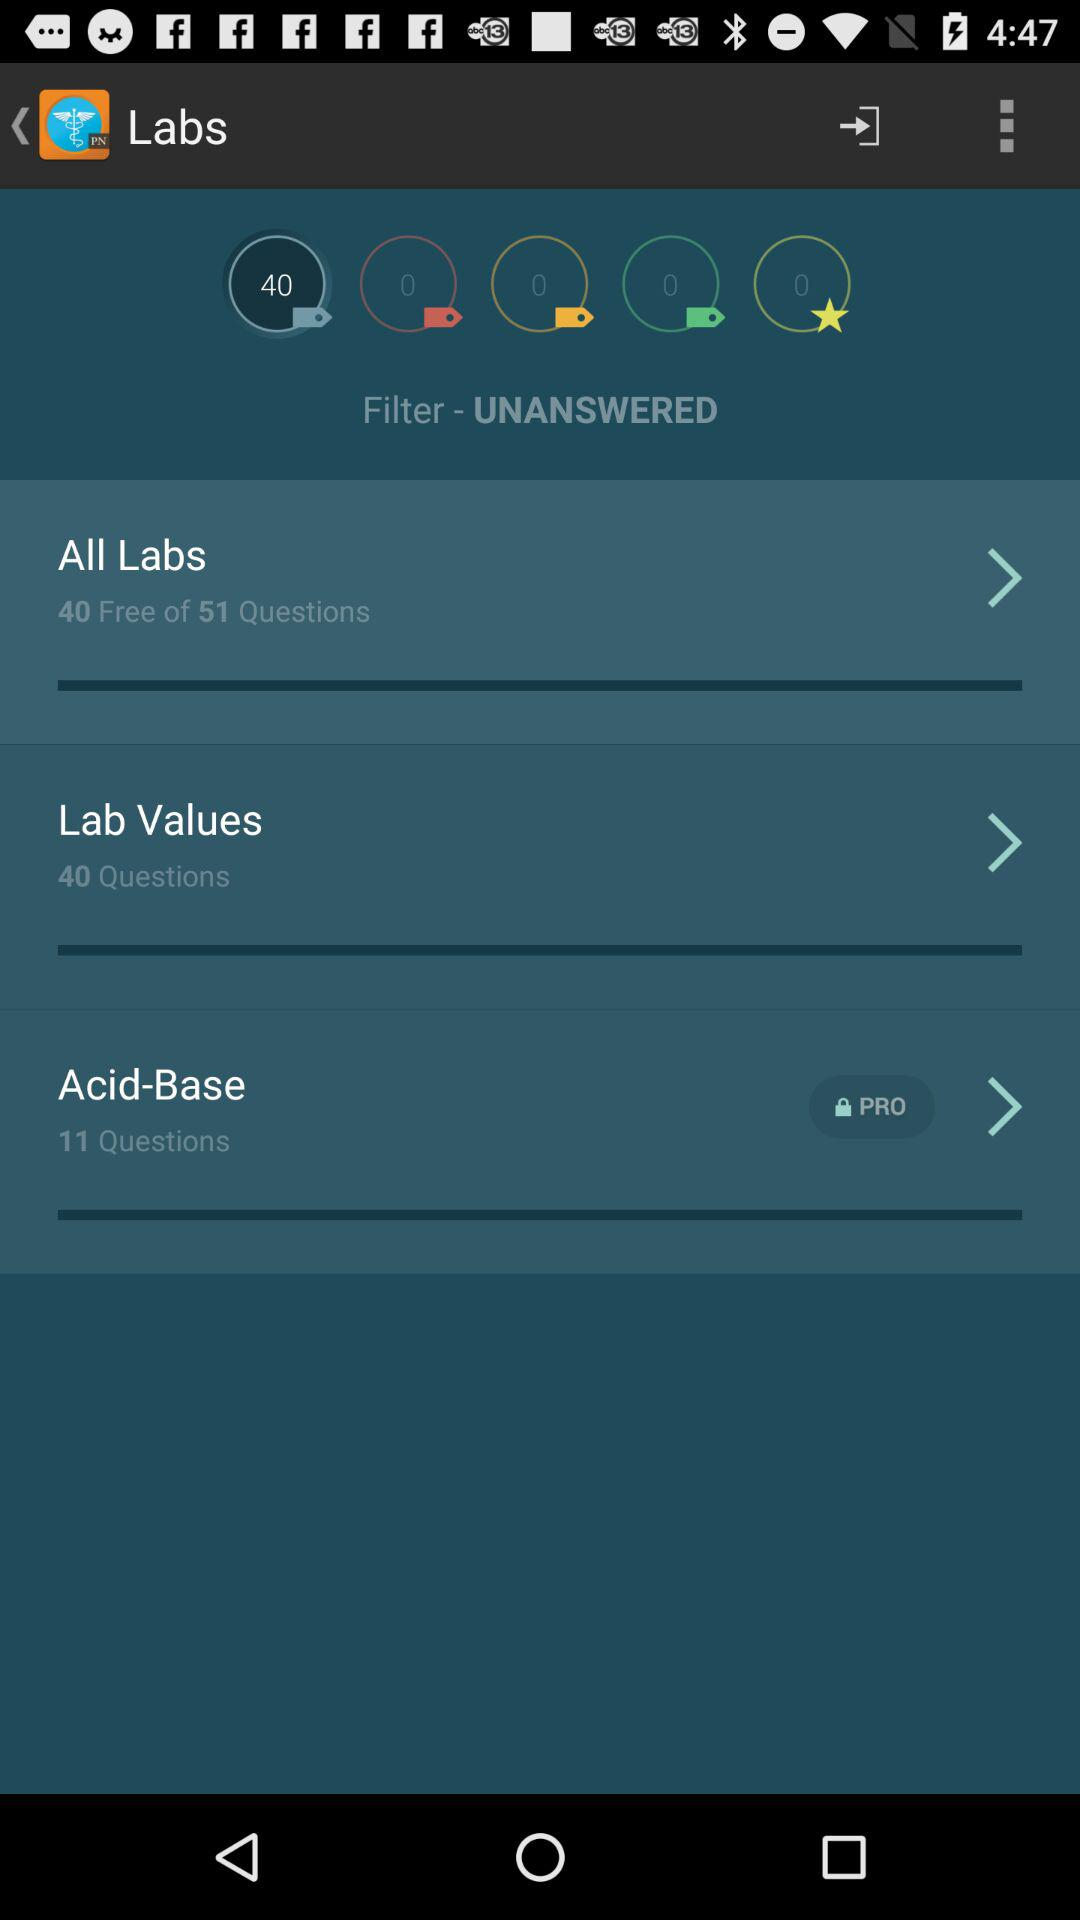What is the total number of questions in "All Labs"? The total number of questions in "All Labs" is 51. 